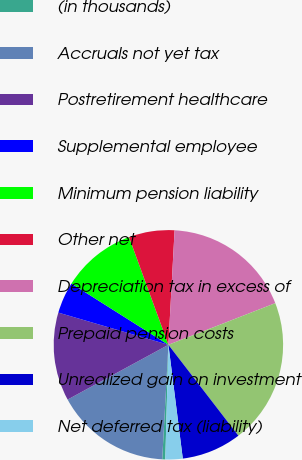Convert chart to OTSL. <chart><loc_0><loc_0><loc_500><loc_500><pie_chart><fcel>(in thousands)<fcel>Accruals not yet tax<fcel>Postretirement healthcare<fcel>Supplemental employee<fcel>Minimum pension liability<fcel>Other net<fcel>Depreciation tax in excess of<fcel>Prepaid pension costs<fcel>Unrealized gain on investment<fcel>Net deferred tax (liability)<nl><fcel>0.43%<fcel>16.22%<fcel>12.45%<fcel>4.44%<fcel>10.45%<fcel>6.44%<fcel>18.23%<fcel>20.47%<fcel>8.44%<fcel>2.43%<nl></chart> 